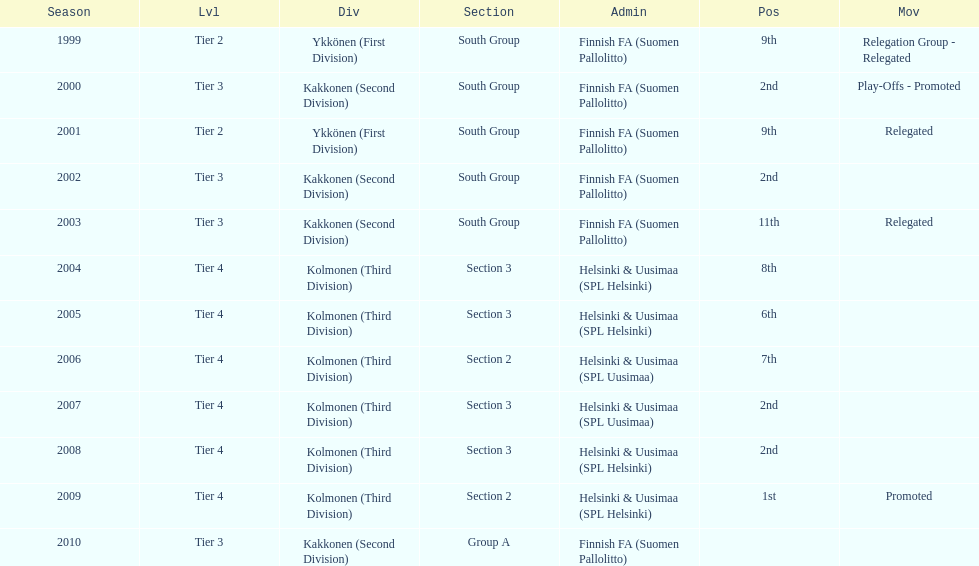Parse the table in full. {'header': ['Season', 'Lvl', 'Div', 'Section', 'Admin', 'Pos', 'Mov'], 'rows': [['1999', 'Tier 2', 'Ykkönen (First Division)', 'South Group', 'Finnish FA (Suomen Pallolitto)', '9th', 'Relegation Group - Relegated'], ['2000', 'Tier 3', 'Kakkonen (Second Division)', 'South Group', 'Finnish FA (Suomen Pallolitto)', '2nd', 'Play-Offs - Promoted'], ['2001', 'Tier 2', 'Ykkönen (First Division)', 'South Group', 'Finnish FA (Suomen Pallolitto)', '9th', 'Relegated'], ['2002', 'Tier 3', 'Kakkonen (Second Division)', 'South Group', 'Finnish FA (Suomen Pallolitto)', '2nd', ''], ['2003', 'Tier 3', 'Kakkonen (Second Division)', 'South Group', 'Finnish FA (Suomen Pallolitto)', '11th', 'Relegated'], ['2004', 'Tier 4', 'Kolmonen (Third Division)', 'Section 3', 'Helsinki & Uusimaa (SPL Helsinki)', '8th', ''], ['2005', 'Tier 4', 'Kolmonen (Third Division)', 'Section 3', 'Helsinki & Uusimaa (SPL Helsinki)', '6th', ''], ['2006', 'Tier 4', 'Kolmonen (Third Division)', 'Section 2', 'Helsinki & Uusimaa (SPL Uusimaa)', '7th', ''], ['2007', 'Tier 4', 'Kolmonen (Third Division)', 'Section 3', 'Helsinki & Uusimaa (SPL Uusimaa)', '2nd', ''], ['2008', 'Tier 4', 'Kolmonen (Third Division)', 'Section 3', 'Helsinki & Uusimaa (SPL Helsinki)', '2nd', ''], ['2009', 'Tier 4', 'Kolmonen (Third Division)', 'Section 2', 'Helsinki & Uusimaa (SPL Helsinki)', '1st', 'Promoted'], ['2010', 'Tier 3', 'Kakkonen (Second Division)', 'Group A', 'Finnish FA (Suomen Pallolitto)', '', '']]} How many consecutive times did they play in tier 4? 6. 